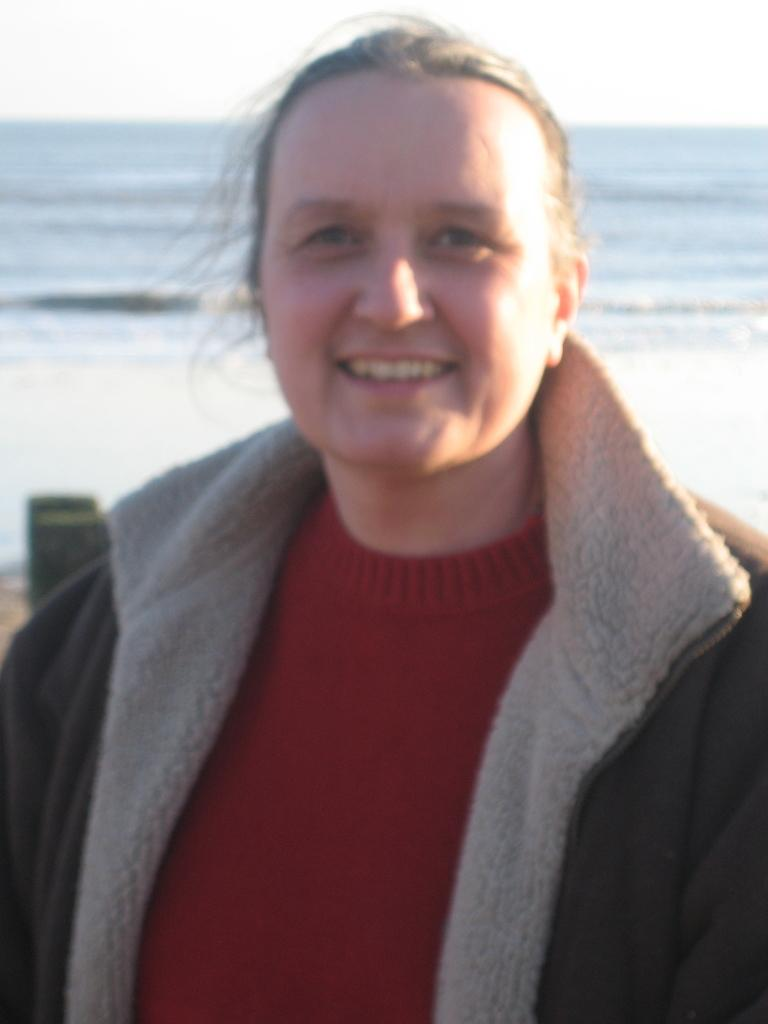Who is present in the image? There is a woman in the image. What is the woman's facial expression? The woman is smiling. What can be seen in the background of the image? Water and the sky are visible in the background of the image. What type of tail can be seen on the rat in the image? There is no rat present in the image, so there is no tail to observe. 